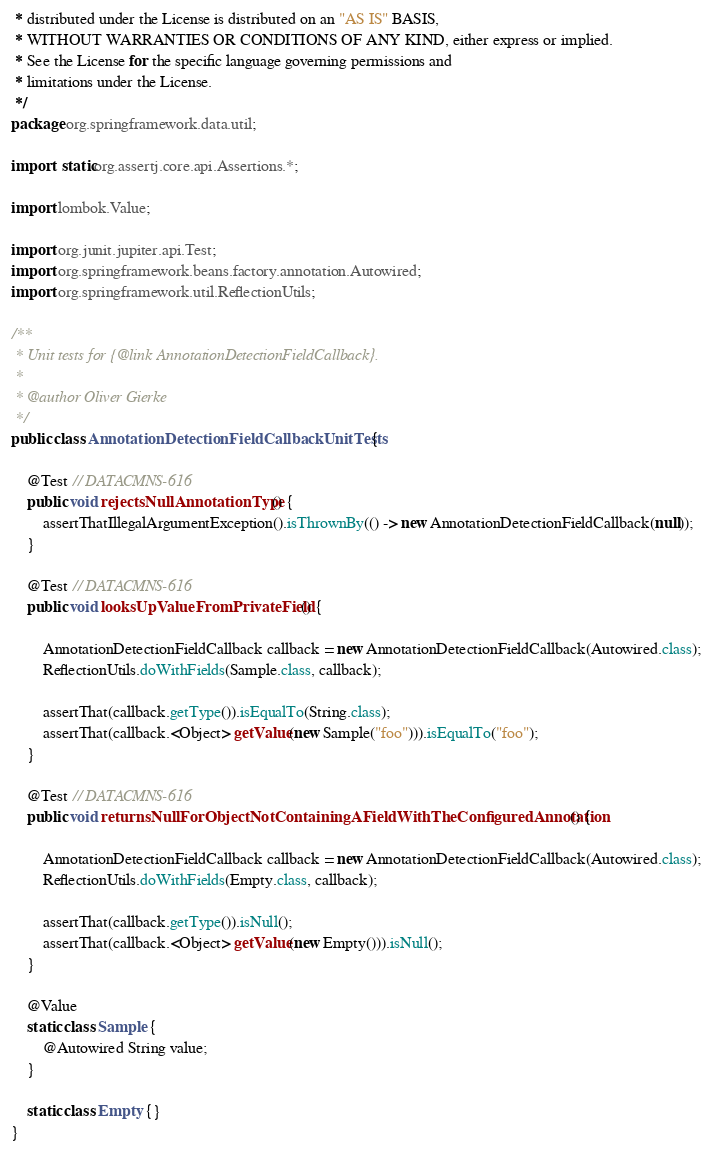<code> <loc_0><loc_0><loc_500><loc_500><_Java_> * distributed under the License is distributed on an "AS IS" BASIS,
 * WITHOUT WARRANTIES OR CONDITIONS OF ANY KIND, either express or implied.
 * See the License for the specific language governing permissions and
 * limitations under the License.
 */
package org.springframework.data.util;

import static org.assertj.core.api.Assertions.*;

import lombok.Value;

import org.junit.jupiter.api.Test;
import org.springframework.beans.factory.annotation.Autowired;
import org.springframework.util.ReflectionUtils;

/**
 * Unit tests for {@link AnnotationDetectionFieldCallback}.
 *
 * @author Oliver Gierke
 */
public class AnnotationDetectionFieldCallbackUnitTests {

	@Test // DATACMNS-616
	public void rejectsNullAnnotationType() {
		assertThatIllegalArgumentException().isThrownBy(() -> new AnnotationDetectionFieldCallback(null));
	}

	@Test // DATACMNS-616
	public void looksUpValueFromPrivateField() {

		AnnotationDetectionFieldCallback callback = new AnnotationDetectionFieldCallback(Autowired.class);
		ReflectionUtils.doWithFields(Sample.class, callback);

		assertThat(callback.getType()).isEqualTo(String.class);
		assertThat(callback.<Object> getValue(new Sample("foo"))).isEqualTo("foo");
	}

	@Test // DATACMNS-616
	public void returnsNullForObjectNotContainingAFieldWithTheConfiguredAnnotation() {

		AnnotationDetectionFieldCallback callback = new AnnotationDetectionFieldCallback(Autowired.class);
		ReflectionUtils.doWithFields(Empty.class, callback);

		assertThat(callback.getType()).isNull();
		assertThat(callback.<Object> getValue(new Empty())).isNull();
	}

	@Value
	static class Sample {
		@Autowired String value;
	}

	static class Empty {}
}
</code> 